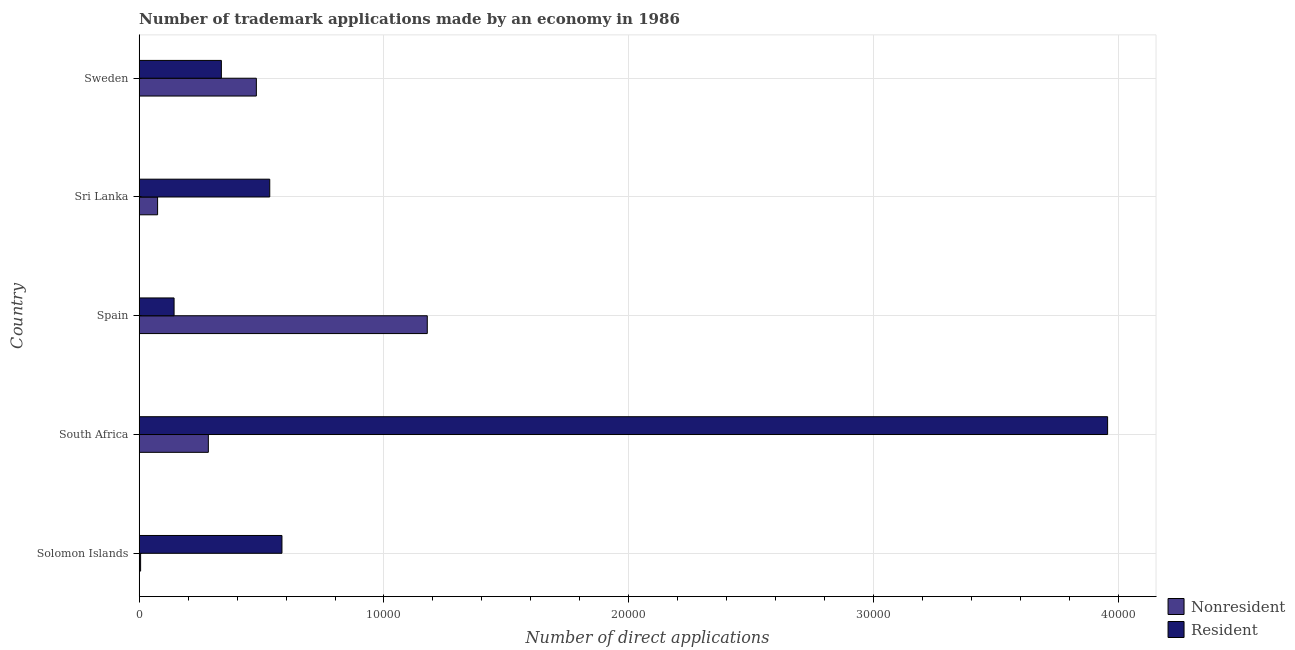How many groups of bars are there?
Keep it short and to the point. 5. Are the number of bars per tick equal to the number of legend labels?
Your answer should be very brief. Yes. Are the number of bars on each tick of the Y-axis equal?
Keep it short and to the point. Yes. How many bars are there on the 3rd tick from the top?
Keep it short and to the point. 2. What is the label of the 5th group of bars from the top?
Your response must be concise. Solomon Islands. In how many cases, is the number of bars for a given country not equal to the number of legend labels?
Give a very brief answer. 0. What is the number of trademark applications made by non residents in South Africa?
Offer a very short reply. 2826. Across all countries, what is the maximum number of trademark applications made by non residents?
Provide a short and direct response. 1.18e+04. Across all countries, what is the minimum number of trademark applications made by non residents?
Provide a short and direct response. 59. In which country was the number of trademark applications made by residents maximum?
Provide a short and direct response. South Africa. What is the total number of trademark applications made by residents in the graph?
Keep it short and to the point. 5.55e+04. What is the difference between the number of trademark applications made by non residents in South Africa and that in Spain?
Keep it short and to the point. -8943. What is the difference between the number of trademark applications made by non residents in Sri Lanka and the number of trademark applications made by residents in Sweden?
Make the answer very short. -2605. What is the average number of trademark applications made by residents per country?
Make the answer very short. 1.11e+04. What is the difference between the number of trademark applications made by non residents and number of trademark applications made by residents in Sri Lanka?
Offer a terse response. -4581. In how many countries, is the number of trademark applications made by residents greater than 16000 ?
Your answer should be compact. 1. What is the ratio of the number of trademark applications made by non residents in Spain to that in Sri Lanka?
Your answer should be very brief. 15.63. Is the difference between the number of trademark applications made by residents in Solomon Islands and Sri Lanka greater than the difference between the number of trademark applications made by non residents in Solomon Islands and Sri Lanka?
Your answer should be compact. Yes. What is the difference between the highest and the second highest number of trademark applications made by non residents?
Provide a short and direct response. 6982. What is the difference between the highest and the lowest number of trademark applications made by non residents?
Your answer should be compact. 1.17e+04. In how many countries, is the number of trademark applications made by non residents greater than the average number of trademark applications made by non residents taken over all countries?
Offer a terse response. 2. Is the sum of the number of trademark applications made by non residents in South Africa and Sweden greater than the maximum number of trademark applications made by residents across all countries?
Keep it short and to the point. No. What does the 2nd bar from the top in Sri Lanka represents?
Provide a succinct answer. Nonresident. What does the 2nd bar from the bottom in South Africa represents?
Your response must be concise. Resident. How many bars are there?
Your answer should be very brief. 10. Does the graph contain any zero values?
Offer a terse response. No. How are the legend labels stacked?
Offer a very short reply. Vertical. What is the title of the graph?
Offer a very short reply. Number of trademark applications made by an economy in 1986. Does "Fertility rate" appear as one of the legend labels in the graph?
Make the answer very short. No. What is the label or title of the X-axis?
Your answer should be very brief. Number of direct applications. What is the label or title of the Y-axis?
Your response must be concise. Country. What is the Number of direct applications of Resident in Solomon Islands?
Give a very brief answer. 5833. What is the Number of direct applications of Nonresident in South Africa?
Provide a succinct answer. 2826. What is the Number of direct applications in Resident in South Africa?
Provide a short and direct response. 3.96e+04. What is the Number of direct applications in Nonresident in Spain?
Keep it short and to the point. 1.18e+04. What is the Number of direct applications of Resident in Spain?
Keep it short and to the point. 1426. What is the Number of direct applications of Nonresident in Sri Lanka?
Make the answer very short. 753. What is the Number of direct applications of Resident in Sri Lanka?
Give a very brief answer. 5334. What is the Number of direct applications of Nonresident in Sweden?
Offer a very short reply. 4787. What is the Number of direct applications in Resident in Sweden?
Make the answer very short. 3358. Across all countries, what is the maximum Number of direct applications of Nonresident?
Give a very brief answer. 1.18e+04. Across all countries, what is the maximum Number of direct applications of Resident?
Your answer should be very brief. 3.96e+04. Across all countries, what is the minimum Number of direct applications in Nonresident?
Keep it short and to the point. 59. Across all countries, what is the minimum Number of direct applications of Resident?
Ensure brevity in your answer.  1426. What is the total Number of direct applications of Nonresident in the graph?
Make the answer very short. 2.02e+04. What is the total Number of direct applications in Resident in the graph?
Keep it short and to the point. 5.55e+04. What is the difference between the Number of direct applications in Nonresident in Solomon Islands and that in South Africa?
Give a very brief answer. -2767. What is the difference between the Number of direct applications of Resident in Solomon Islands and that in South Africa?
Provide a succinct answer. -3.37e+04. What is the difference between the Number of direct applications in Nonresident in Solomon Islands and that in Spain?
Make the answer very short. -1.17e+04. What is the difference between the Number of direct applications of Resident in Solomon Islands and that in Spain?
Provide a short and direct response. 4407. What is the difference between the Number of direct applications in Nonresident in Solomon Islands and that in Sri Lanka?
Ensure brevity in your answer.  -694. What is the difference between the Number of direct applications in Resident in Solomon Islands and that in Sri Lanka?
Provide a short and direct response. 499. What is the difference between the Number of direct applications of Nonresident in Solomon Islands and that in Sweden?
Your answer should be very brief. -4728. What is the difference between the Number of direct applications of Resident in Solomon Islands and that in Sweden?
Provide a succinct answer. 2475. What is the difference between the Number of direct applications of Nonresident in South Africa and that in Spain?
Ensure brevity in your answer.  -8943. What is the difference between the Number of direct applications in Resident in South Africa and that in Spain?
Provide a succinct answer. 3.81e+04. What is the difference between the Number of direct applications in Nonresident in South Africa and that in Sri Lanka?
Your answer should be very brief. 2073. What is the difference between the Number of direct applications of Resident in South Africa and that in Sri Lanka?
Make the answer very short. 3.42e+04. What is the difference between the Number of direct applications in Nonresident in South Africa and that in Sweden?
Provide a succinct answer. -1961. What is the difference between the Number of direct applications in Resident in South Africa and that in Sweden?
Give a very brief answer. 3.62e+04. What is the difference between the Number of direct applications in Nonresident in Spain and that in Sri Lanka?
Your answer should be very brief. 1.10e+04. What is the difference between the Number of direct applications of Resident in Spain and that in Sri Lanka?
Give a very brief answer. -3908. What is the difference between the Number of direct applications of Nonresident in Spain and that in Sweden?
Your response must be concise. 6982. What is the difference between the Number of direct applications of Resident in Spain and that in Sweden?
Make the answer very short. -1932. What is the difference between the Number of direct applications in Nonresident in Sri Lanka and that in Sweden?
Keep it short and to the point. -4034. What is the difference between the Number of direct applications of Resident in Sri Lanka and that in Sweden?
Make the answer very short. 1976. What is the difference between the Number of direct applications in Nonresident in Solomon Islands and the Number of direct applications in Resident in South Africa?
Your answer should be very brief. -3.95e+04. What is the difference between the Number of direct applications in Nonresident in Solomon Islands and the Number of direct applications in Resident in Spain?
Offer a very short reply. -1367. What is the difference between the Number of direct applications in Nonresident in Solomon Islands and the Number of direct applications in Resident in Sri Lanka?
Your answer should be compact. -5275. What is the difference between the Number of direct applications of Nonresident in Solomon Islands and the Number of direct applications of Resident in Sweden?
Provide a short and direct response. -3299. What is the difference between the Number of direct applications of Nonresident in South Africa and the Number of direct applications of Resident in Spain?
Your answer should be compact. 1400. What is the difference between the Number of direct applications in Nonresident in South Africa and the Number of direct applications in Resident in Sri Lanka?
Make the answer very short. -2508. What is the difference between the Number of direct applications of Nonresident in South Africa and the Number of direct applications of Resident in Sweden?
Your answer should be very brief. -532. What is the difference between the Number of direct applications of Nonresident in Spain and the Number of direct applications of Resident in Sri Lanka?
Your answer should be compact. 6435. What is the difference between the Number of direct applications in Nonresident in Spain and the Number of direct applications in Resident in Sweden?
Give a very brief answer. 8411. What is the difference between the Number of direct applications in Nonresident in Sri Lanka and the Number of direct applications in Resident in Sweden?
Provide a succinct answer. -2605. What is the average Number of direct applications of Nonresident per country?
Provide a succinct answer. 4038.8. What is the average Number of direct applications in Resident per country?
Your response must be concise. 1.11e+04. What is the difference between the Number of direct applications of Nonresident and Number of direct applications of Resident in Solomon Islands?
Ensure brevity in your answer.  -5774. What is the difference between the Number of direct applications of Nonresident and Number of direct applications of Resident in South Africa?
Your answer should be compact. -3.67e+04. What is the difference between the Number of direct applications of Nonresident and Number of direct applications of Resident in Spain?
Offer a terse response. 1.03e+04. What is the difference between the Number of direct applications of Nonresident and Number of direct applications of Resident in Sri Lanka?
Your response must be concise. -4581. What is the difference between the Number of direct applications of Nonresident and Number of direct applications of Resident in Sweden?
Provide a short and direct response. 1429. What is the ratio of the Number of direct applications in Nonresident in Solomon Islands to that in South Africa?
Ensure brevity in your answer.  0.02. What is the ratio of the Number of direct applications in Resident in Solomon Islands to that in South Africa?
Your answer should be very brief. 0.15. What is the ratio of the Number of direct applications of Nonresident in Solomon Islands to that in Spain?
Keep it short and to the point. 0.01. What is the ratio of the Number of direct applications of Resident in Solomon Islands to that in Spain?
Your answer should be compact. 4.09. What is the ratio of the Number of direct applications in Nonresident in Solomon Islands to that in Sri Lanka?
Provide a succinct answer. 0.08. What is the ratio of the Number of direct applications in Resident in Solomon Islands to that in Sri Lanka?
Your answer should be very brief. 1.09. What is the ratio of the Number of direct applications of Nonresident in Solomon Islands to that in Sweden?
Make the answer very short. 0.01. What is the ratio of the Number of direct applications in Resident in Solomon Islands to that in Sweden?
Provide a short and direct response. 1.74. What is the ratio of the Number of direct applications in Nonresident in South Africa to that in Spain?
Offer a terse response. 0.24. What is the ratio of the Number of direct applications of Resident in South Africa to that in Spain?
Make the answer very short. 27.74. What is the ratio of the Number of direct applications in Nonresident in South Africa to that in Sri Lanka?
Your answer should be compact. 3.75. What is the ratio of the Number of direct applications of Resident in South Africa to that in Sri Lanka?
Your answer should be compact. 7.42. What is the ratio of the Number of direct applications of Nonresident in South Africa to that in Sweden?
Offer a terse response. 0.59. What is the ratio of the Number of direct applications of Resident in South Africa to that in Sweden?
Your answer should be compact. 11.78. What is the ratio of the Number of direct applications in Nonresident in Spain to that in Sri Lanka?
Your response must be concise. 15.63. What is the ratio of the Number of direct applications of Resident in Spain to that in Sri Lanka?
Offer a terse response. 0.27. What is the ratio of the Number of direct applications of Nonresident in Spain to that in Sweden?
Provide a short and direct response. 2.46. What is the ratio of the Number of direct applications in Resident in Spain to that in Sweden?
Ensure brevity in your answer.  0.42. What is the ratio of the Number of direct applications of Nonresident in Sri Lanka to that in Sweden?
Keep it short and to the point. 0.16. What is the ratio of the Number of direct applications in Resident in Sri Lanka to that in Sweden?
Offer a terse response. 1.59. What is the difference between the highest and the second highest Number of direct applications in Nonresident?
Give a very brief answer. 6982. What is the difference between the highest and the second highest Number of direct applications in Resident?
Provide a succinct answer. 3.37e+04. What is the difference between the highest and the lowest Number of direct applications of Nonresident?
Offer a very short reply. 1.17e+04. What is the difference between the highest and the lowest Number of direct applications in Resident?
Keep it short and to the point. 3.81e+04. 